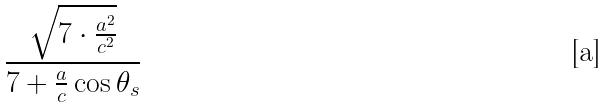<formula> <loc_0><loc_0><loc_500><loc_500>\frac { \sqrt { 7 \cdot \frac { a ^ { 2 } } { c ^ { 2 } } } } { 7 + \frac { a } { c } \cos \theta _ { s } }</formula> 